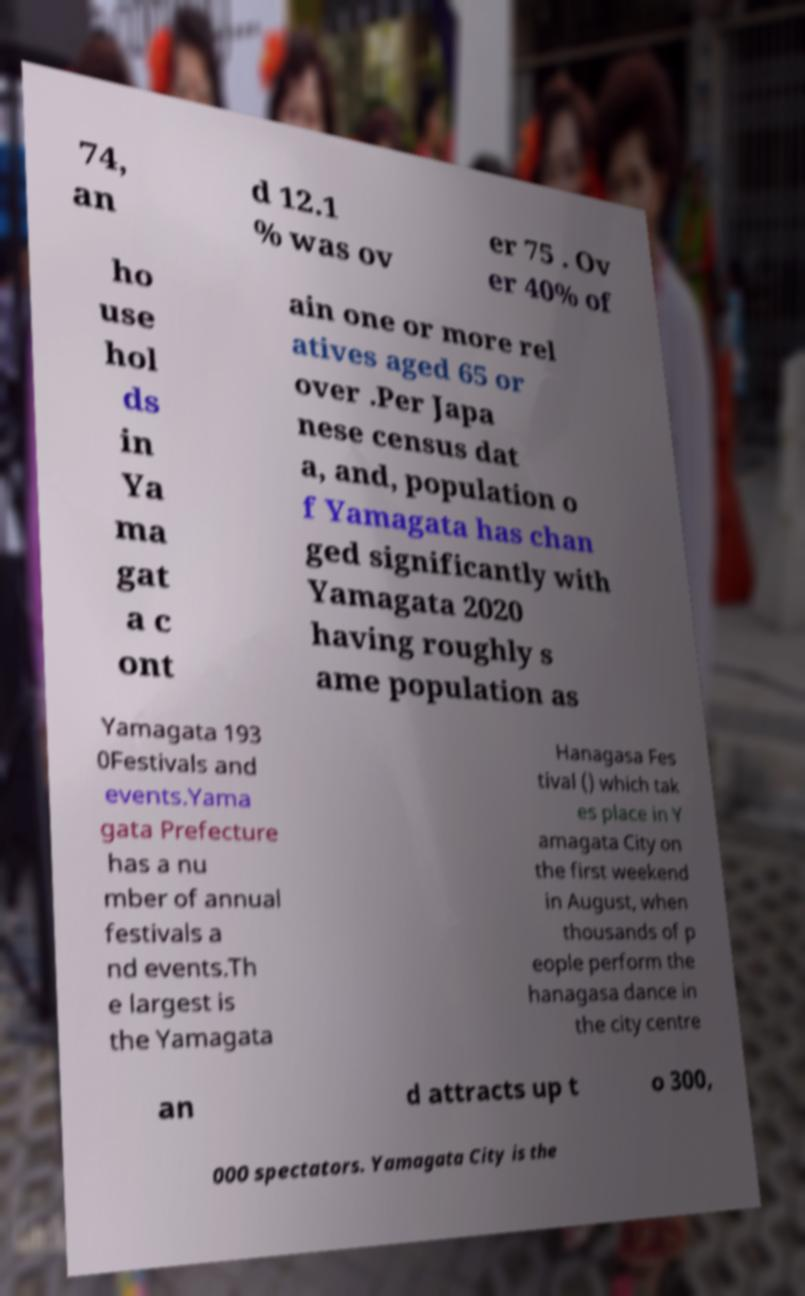Please read and relay the text visible in this image. What does it say? 74, an d 12.1 % was ov er 75 . Ov er 40% of ho use hol ds in Ya ma gat a c ont ain one or more rel atives aged 65 or over .Per Japa nese census dat a, and, population o f Yamagata has chan ged significantly with Yamagata 2020 having roughly s ame population as Yamagata 193 0Festivals and events.Yama gata Prefecture has a nu mber of annual festivals a nd events.Th e largest is the Yamagata Hanagasa Fes tival () which tak es place in Y amagata City on the first weekend in August, when thousands of p eople perform the hanagasa dance in the city centre an d attracts up t o 300, 000 spectators. Yamagata City is the 